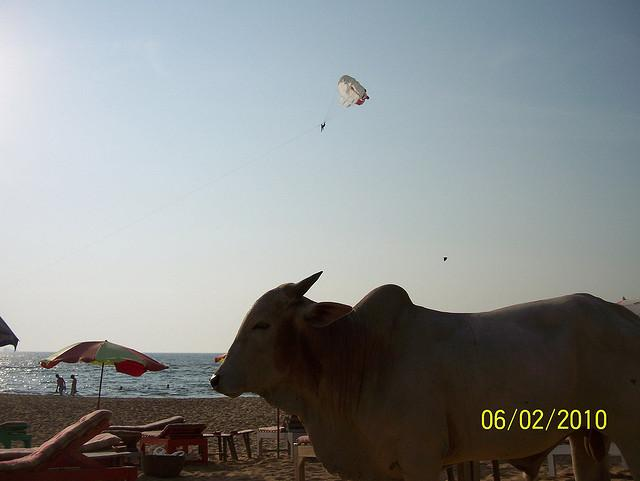What country is this beach located in? india 